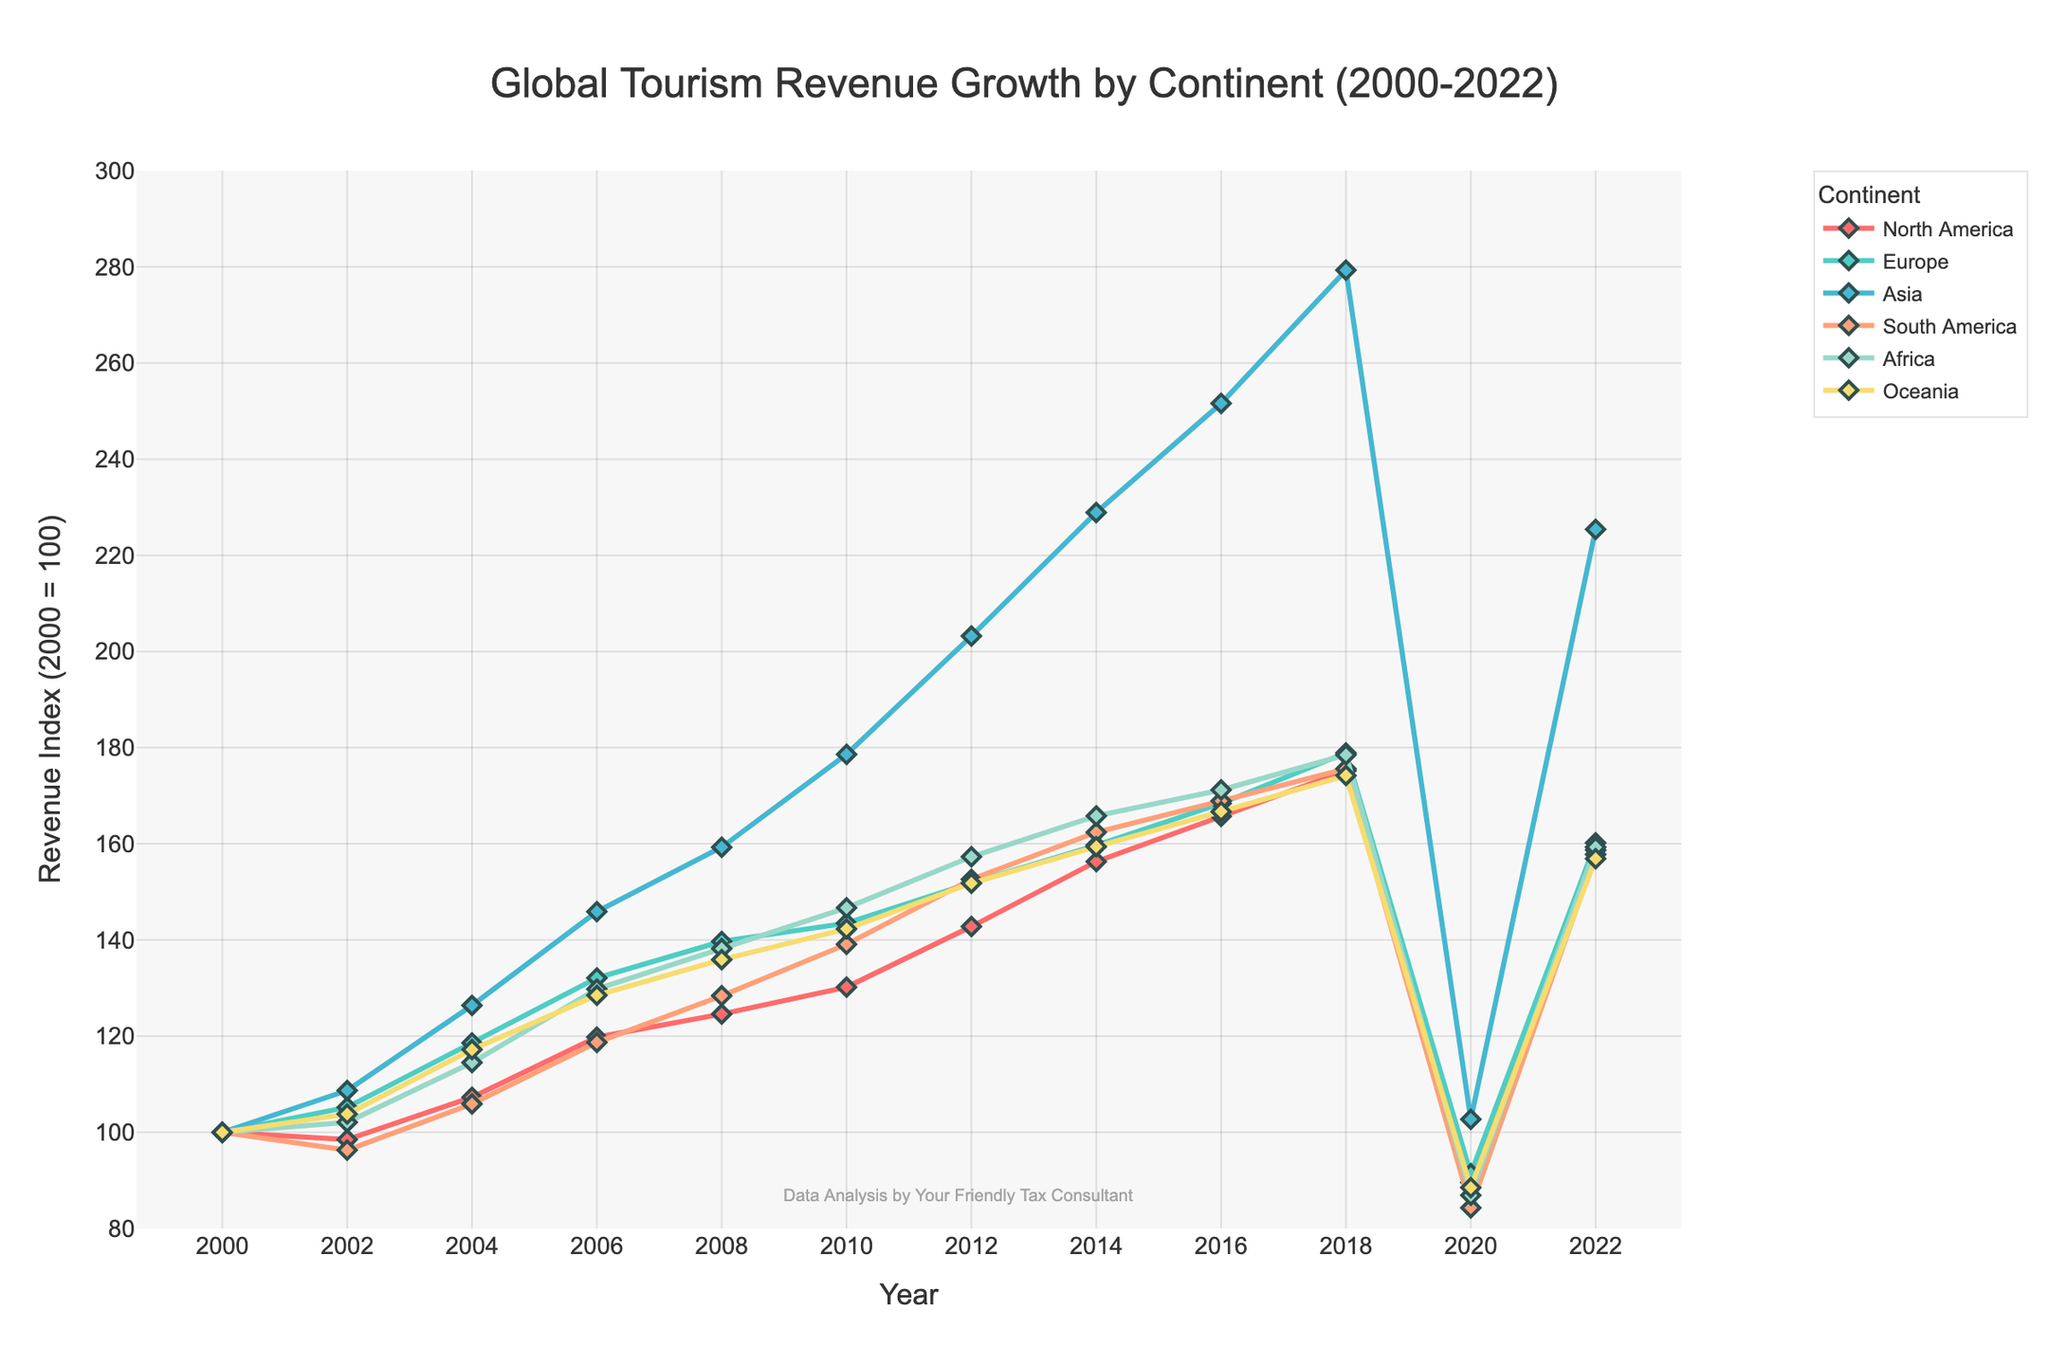What is the highest revenue index recorded for Asia? The highest revenue index for Asia can be determined by looking at the line corresponding to Asia (usually marked in a distinct color) and finding the peak value. The peak value for Asia is observed in 2018 with an index of 279.3.
Answer: 279.3 Which continent saw the largest decrease in revenue index between 2018 and 2020? To identify the continent with the largest decrease, calculate the difference in revenue index for each continent between 2018 and 2020. The differences are: North America (175.2 - 89.6 = 85.6), Europe (178.9 - 91.4 = 87.5), Asia (279.3 - 102.7 = 176.6), South America (175.6 - 84.3 = 91.3), Africa (178.5 - 86.9 = 91.6), Oceania (174.2 - 88.5 = 85.7). Asia has the largest decrease.
Answer: Asia Between 2004 and 2022, which continent experienced the least growth in revenue index? Calculate the growth in revenue index for each continent from 2004 to 2022: North America (158.7 - 107.3 = 51.4), Europe (160.2 - 118.6 = 41.6), Asia (225.4 - 126.4 = 99), South America (157.8 - 105.9 = 51.9), Africa (159.3 - 114.5 = 44.8), Oceania (156.9 - 117.2 = 39.7). Oceania experienced the least growth.
Answer: Oceania What is the visual color used to represent Europe on the chart? By inspecting the legend in the chart, the line corresponding to Europe is represented by a specific color. Visually, it should be identifiable without referring to any code.
Answer: Green (or the specified color in the code) By how much did the revenue index for South America change between 2000 and 2006? The revenue index for South America in 2000 was 100, and in 2006 it was 118.7. The change is calculated as 118.7 - 100.
Answer: 18.7 In which year did North America first exceed the revenue index of 160? Look for the point in the North America line graph where it first exceeds an index of 160. This happens in 2016.
Answer: 2016 Which continent had the highest revenue index in 2014? Compare the revenue indices for all the continents in 2014: North America (156.3), Europe (159.7), Asia (228.9), South America (162.4), Africa (165.8), Oceania (159.4). Asia had the highest revenue index.
Answer: Asia What is the general trend of global tourism revenue indices for continents from 2000 to 2022? Observe the overall direction of the lines in the chart from 2000 to 2022. Most continents show an increasing trend until 2018, followed by a sharp decline around 2020, and then a recovery phase by 2022.
Answer: Increasing until 2018, a sharp decline in 2020, followed by recovery 